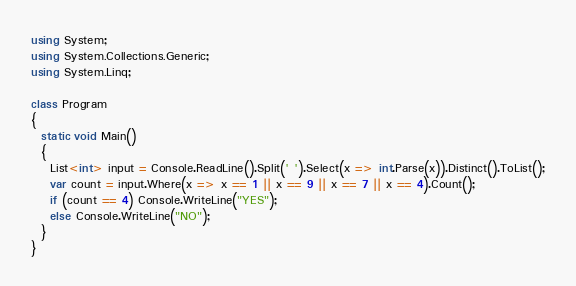Convert code to text. <code><loc_0><loc_0><loc_500><loc_500><_C#_>using System;
using System.Collections.Generic;
using System.Linq;

class Program
{
  static void Main()
  {
    List<int> input = Console.ReadLine().Split(' ').Select(x => int.Parse(x)).Distinct().ToList();
    var count = input.Where(x => x == 1 || x == 9 || x == 7 || x == 4).Count();
    if (count == 4) Console.WriteLine("YES");
    else Console.WriteLine("NO");
  }
}
</code> 